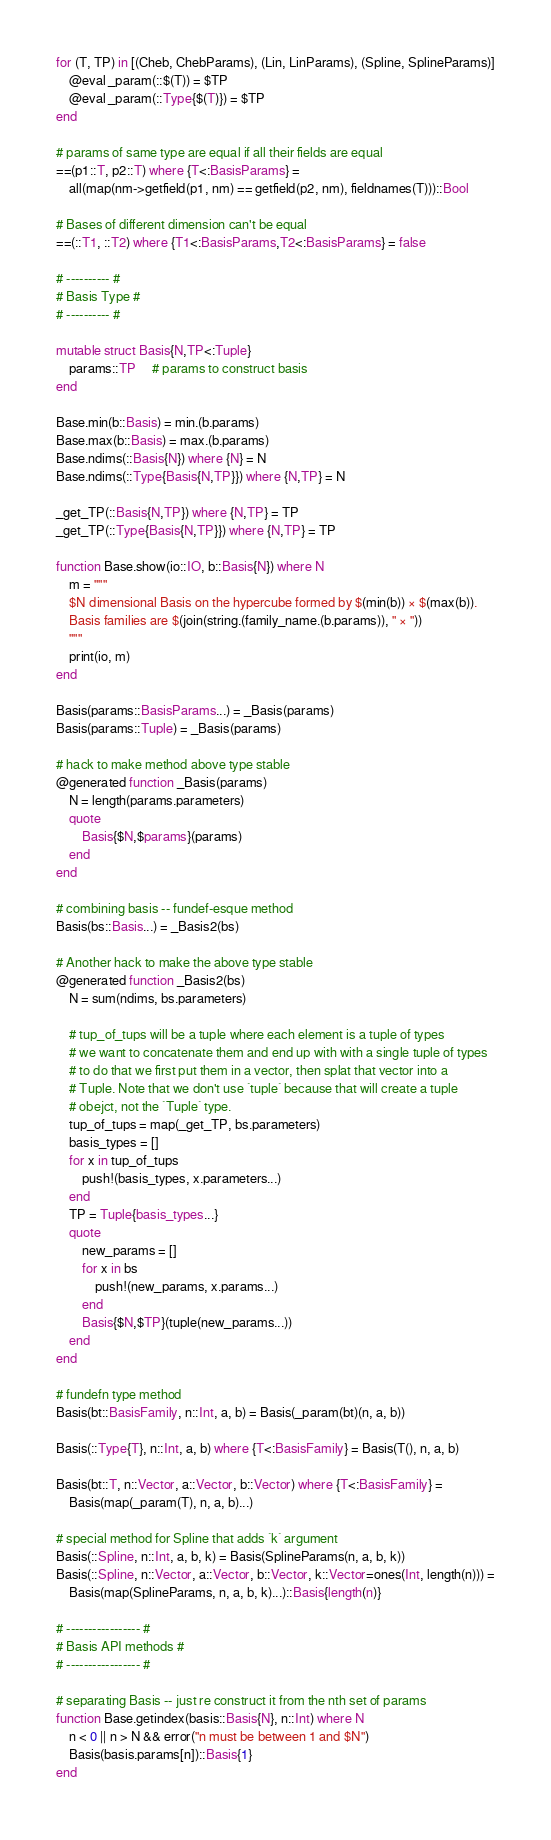Convert code to text. <code><loc_0><loc_0><loc_500><loc_500><_Julia_>for (T, TP) in [(Cheb, ChebParams), (Lin, LinParams), (Spline, SplineParams)]
    @eval _param(::$(T)) = $TP
    @eval _param(::Type{$(T)}) = $TP
end

# params of same type are equal if all their fields are equal
==(p1::T, p2::T) where {T<:BasisParams} =
    all(map(nm->getfield(p1, nm) == getfield(p2, nm), fieldnames(T)))::Bool

# Bases of different dimension can't be equal
==(::T1, ::T2) where {T1<:BasisParams,T2<:BasisParams} = false

# ---------- #
# Basis Type #
# ---------- #

mutable struct Basis{N,TP<:Tuple}
    params::TP     # params to construct basis
end

Base.min(b::Basis) = min.(b.params)
Base.max(b::Basis) = max.(b.params)
Base.ndims(::Basis{N}) where {N} = N
Base.ndims(::Type{Basis{N,TP}}) where {N,TP} = N

_get_TP(::Basis{N,TP}) where {N,TP} = TP
_get_TP(::Type{Basis{N,TP}}) where {N,TP} = TP

function Base.show(io::IO, b::Basis{N}) where N
    m = """
    $N dimensional Basis on the hypercube formed by $(min(b)) × $(max(b)).
    Basis families are $(join(string.(family_name.(b.params)), " × "))
    """
    print(io, m)
end

Basis(params::BasisParams...) = _Basis(params)
Basis(params::Tuple) = _Basis(params)

# hack to make method above type stable
@generated function _Basis(params)
    N = length(params.parameters)
    quote
        Basis{$N,$params}(params)
    end
end

# combining basis -- fundef-esque method
Basis(bs::Basis...) = _Basis2(bs)

# Another hack to make the above type stable
@generated function _Basis2(bs)
    N = sum(ndims, bs.parameters)

    # tup_of_tups will be a tuple where each element is a tuple of types
    # we want to concatenate them and end up with with a single tuple of types
    # to do that we first put them in a vector, then splat that vector into a
    # Tuple. Note that we don't use `tuple` because that will create a tuple
    # obejct, not the `Tuple` type.
    tup_of_tups = map(_get_TP, bs.parameters)
    basis_types = []
    for x in tup_of_tups
        push!(basis_types, x.parameters...)
    end
    TP = Tuple{basis_types...}
    quote
        new_params = []
        for x in bs
            push!(new_params, x.params...)
        end
        Basis{$N,$TP}(tuple(new_params...))
    end
end

# fundefn type method
Basis(bt::BasisFamily, n::Int, a, b) = Basis(_param(bt)(n, a, b))

Basis(::Type{T}, n::Int, a, b) where {T<:BasisFamily} = Basis(T(), n, a, b)

Basis(bt::T, n::Vector, a::Vector, b::Vector) where {T<:BasisFamily} =
    Basis(map(_param(T), n, a, b)...)

# special method for Spline that adds `k` argument
Basis(::Spline, n::Int, a, b, k) = Basis(SplineParams(n, a, b, k))
Basis(::Spline, n::Vector, a::Vector, b::Vector, k::Vector=ones(Int, length(n))) =
    Basis(map(SplineParams, n, a, b, k)...)::Basis{length(n)}

# ----------------- #
# Basis API methods #
# ----------------- #

# separating Basis -- just re construct it from the nth set of params
function Base.getindex(basis::Basis{N}, n::Int) where N
    n < 0 || n > N && error("n must be between 1 and $N")
    Basis(basis.params[n])::Basis{1}
end
</code> 